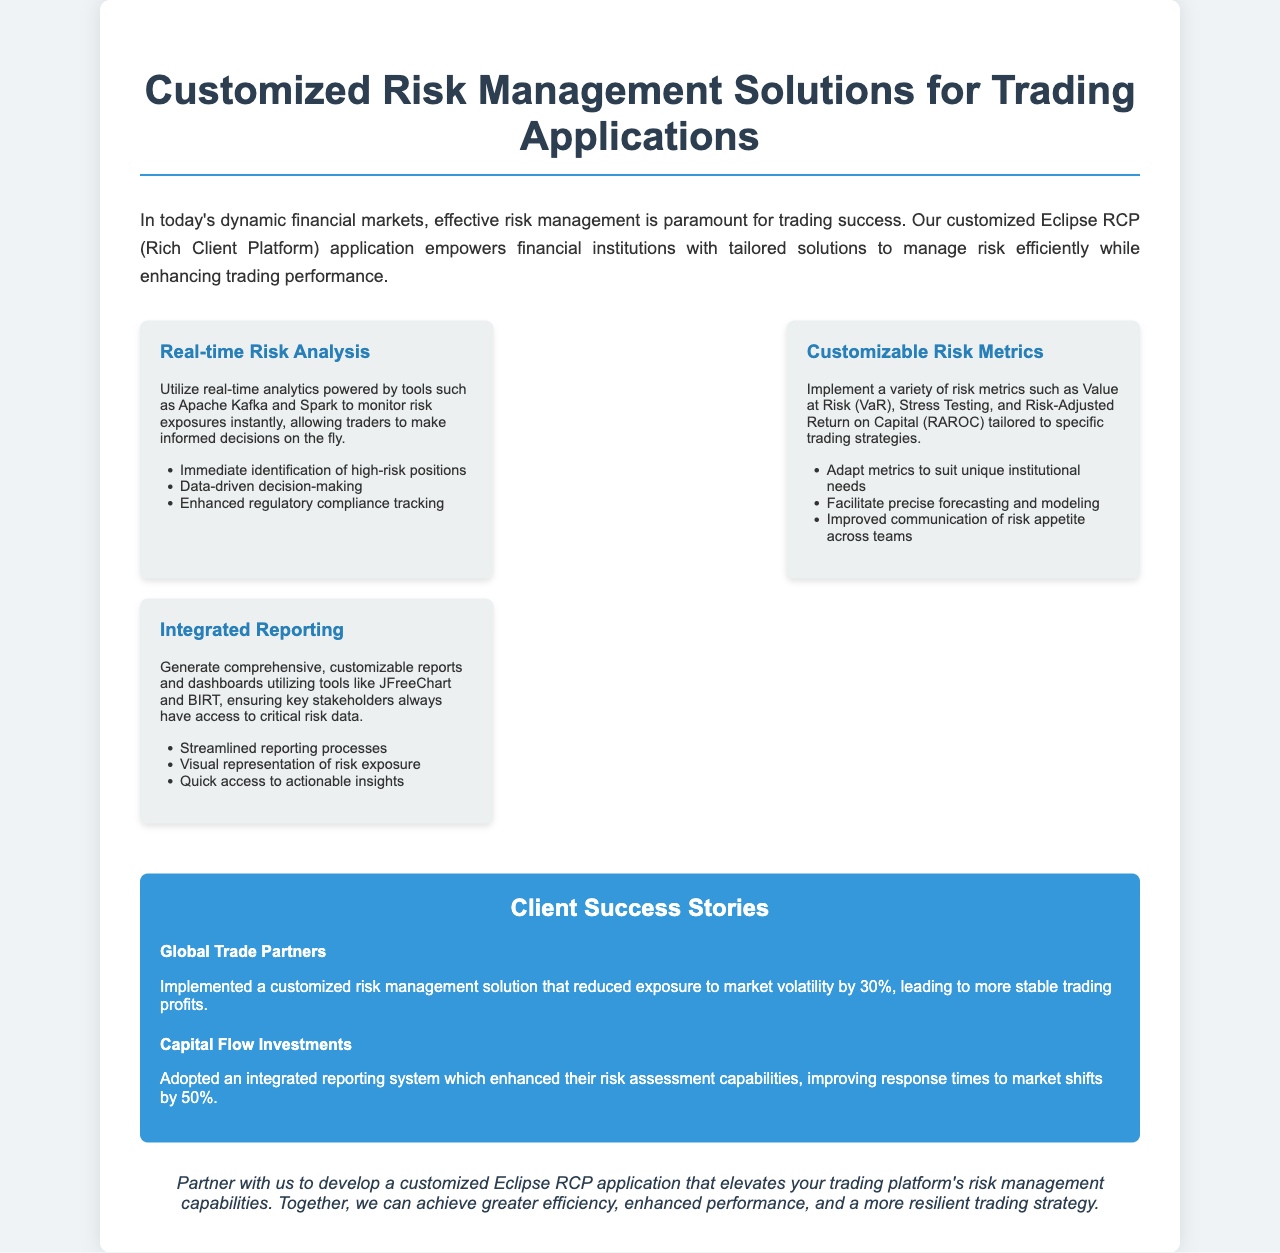what is the title of the brochure? The title of the brochure is prominently displayed at the top of the document.
Answer: Customized Risk Management Solutions for Trading Applications what is the main benefit of the Eclipse RCP application? The main benefit is mentioned in the introduction as empowering financial institutions with tailored solutions to manage risk efficiently.
Answer: Tailored solutions to manage risk efficiently how many client success stories are provided? The document includes a section dedicated to client success stories.
Answer: Two which risk metric is mentioned first in the customizable risk metrics section? The first risk metric listed under customizable risk metrics is identified in the document.
Answer: Value at Risk (VaR) what percentage did Global Trade Partners reduce their exposure to market volatility? The document provides specific results from client success stories, including a percentage related to market volatility.
Answer: 30% which tool is used for integrated reporting? The brochure states the tools used for generating reports and dashboards in the integrated reporting feature.
Answer: JFreeChart and BIRT how much did Capital Flow Investments improve their response times to market shifts? The document specifies improvements made by Capital Flow Investments regarding their response times to market shifts.
Answer: 50% what is the color of the success stories section? The document describes the design choices, including color, for the success stories section.
Answer: Blue 